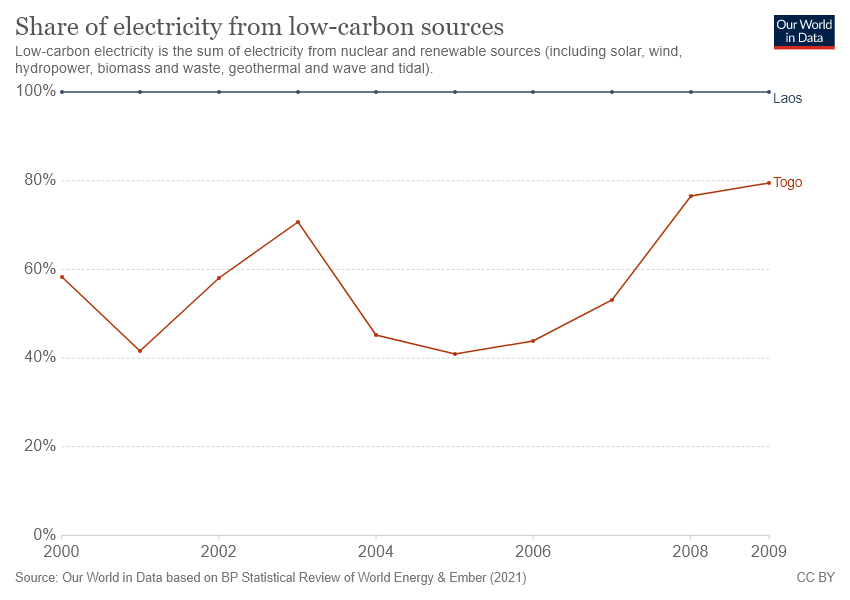What does the brown line represent? The brown line on the chart indicates the percentage of electricity in Togo that comes from low-carbon sources, including nuclear and various renewable energy sources like solar, wind, hydroelectric power, biomass, waste, geothermal, and marine sources over the span from 2000 to 2009. Notably, there's a decrease around the mid-2000s, followed by a steady increase towards the end of the decade. 